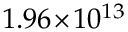Convert formula to latex. <formula><loc_0><loc_0><loc_500><loc_500>1 . 9 6 \, \times \, 1 0 ^ { 1 3 }</formula> 